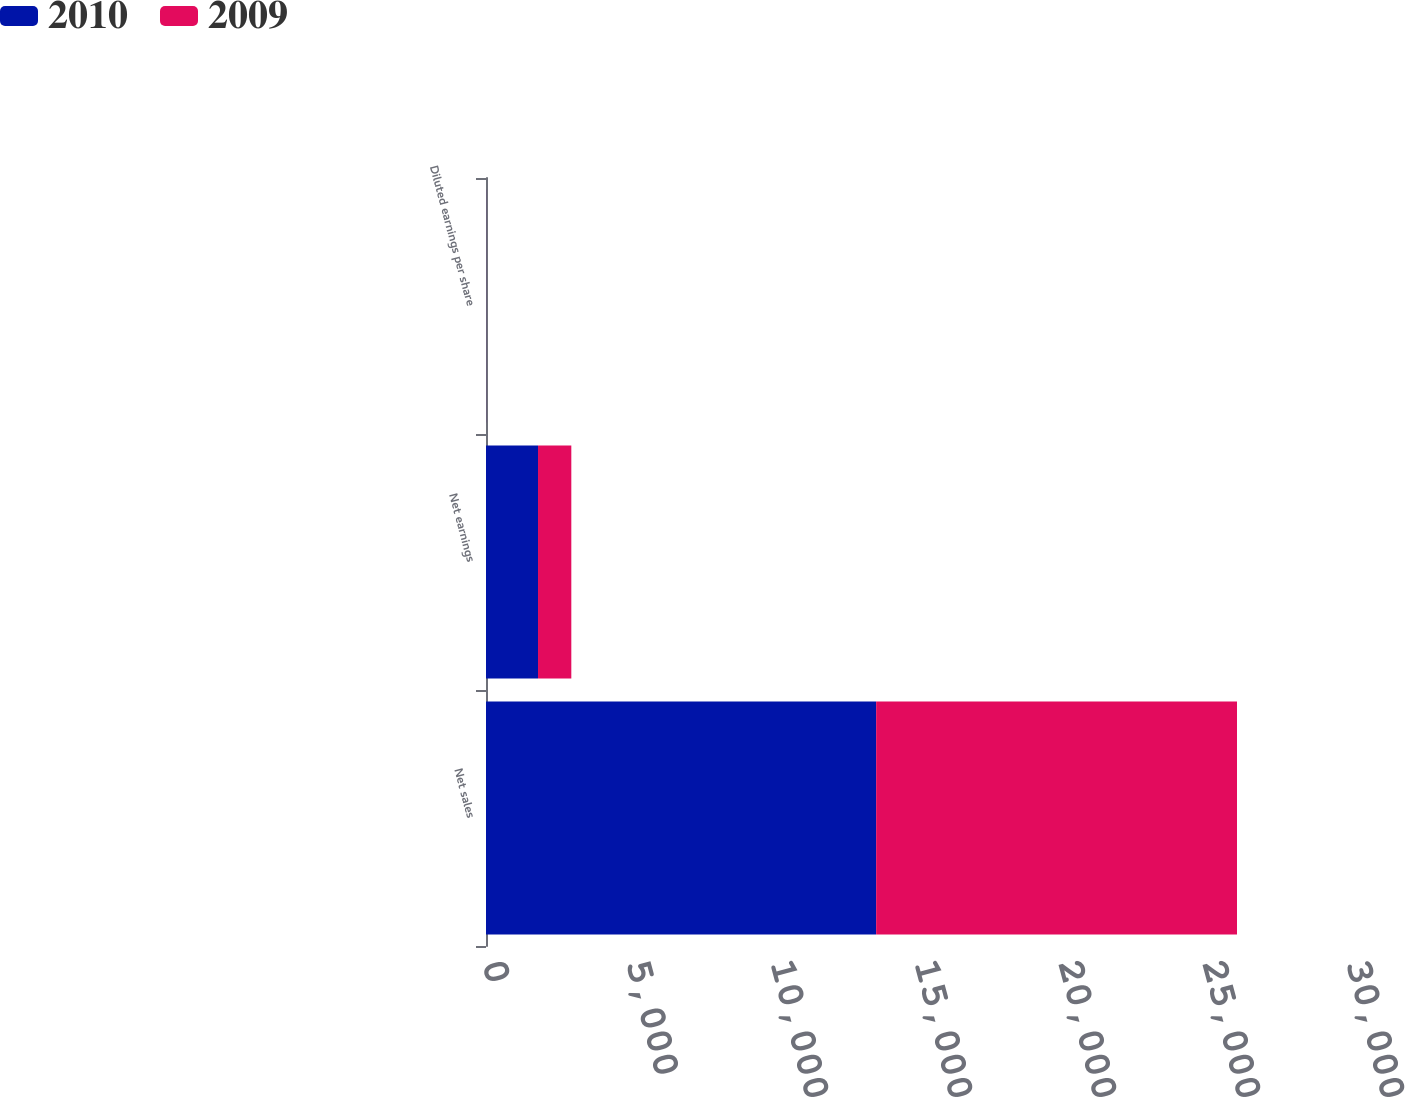Convert chart. <chart><loc_0><loc_0><loc_500><loc_500><stacked_bar_chart><ecel><fcel>Net sales<fcel>Net earnings<fcel>Diluted earnings per share<nl><fcel>2010<fcel>13546.8<fcel>1806.1<fcel>2.66<nl><fcel>2009<fcel>12529.5<fcel>1156.2<fcel>1.74<nl></chart> 